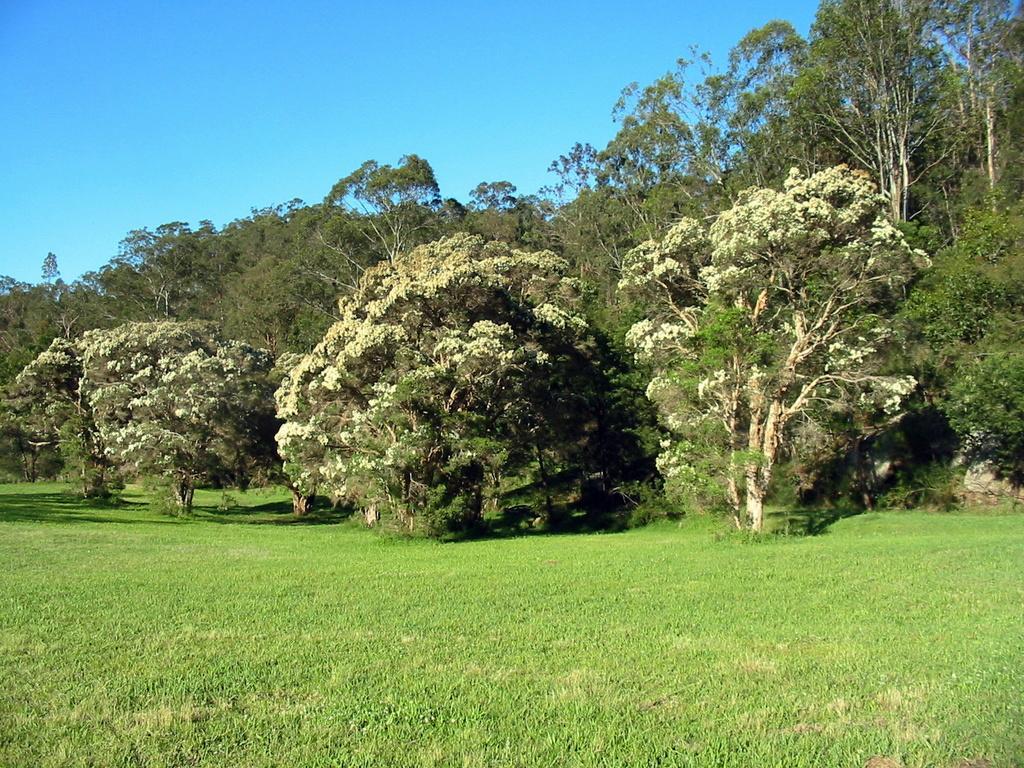Please provide a concise description of this image. In this image we can see trees, grass and sky. 